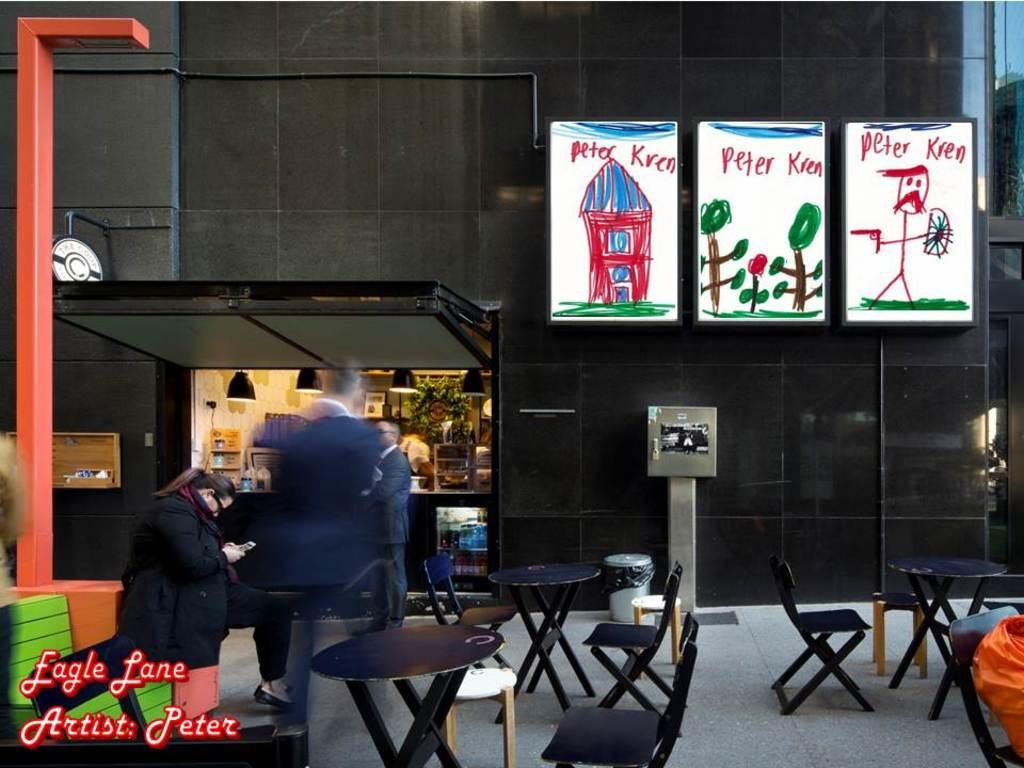What is the woman doing in the image? The woman is sitting on a chair in the image. What is the man doing in the image? The man is standing in the image. Can you describe the lighting in the image? There is a light in the image. What type of establishment is depicted in the image? There is a shop in the image. What decorative elements are present on the building? There are posters on the building. What type of twig is the woman holding in the image? There is no twig present in the image. What does the creature on the man's shoulder say in the image? There is no creature present in the image. 